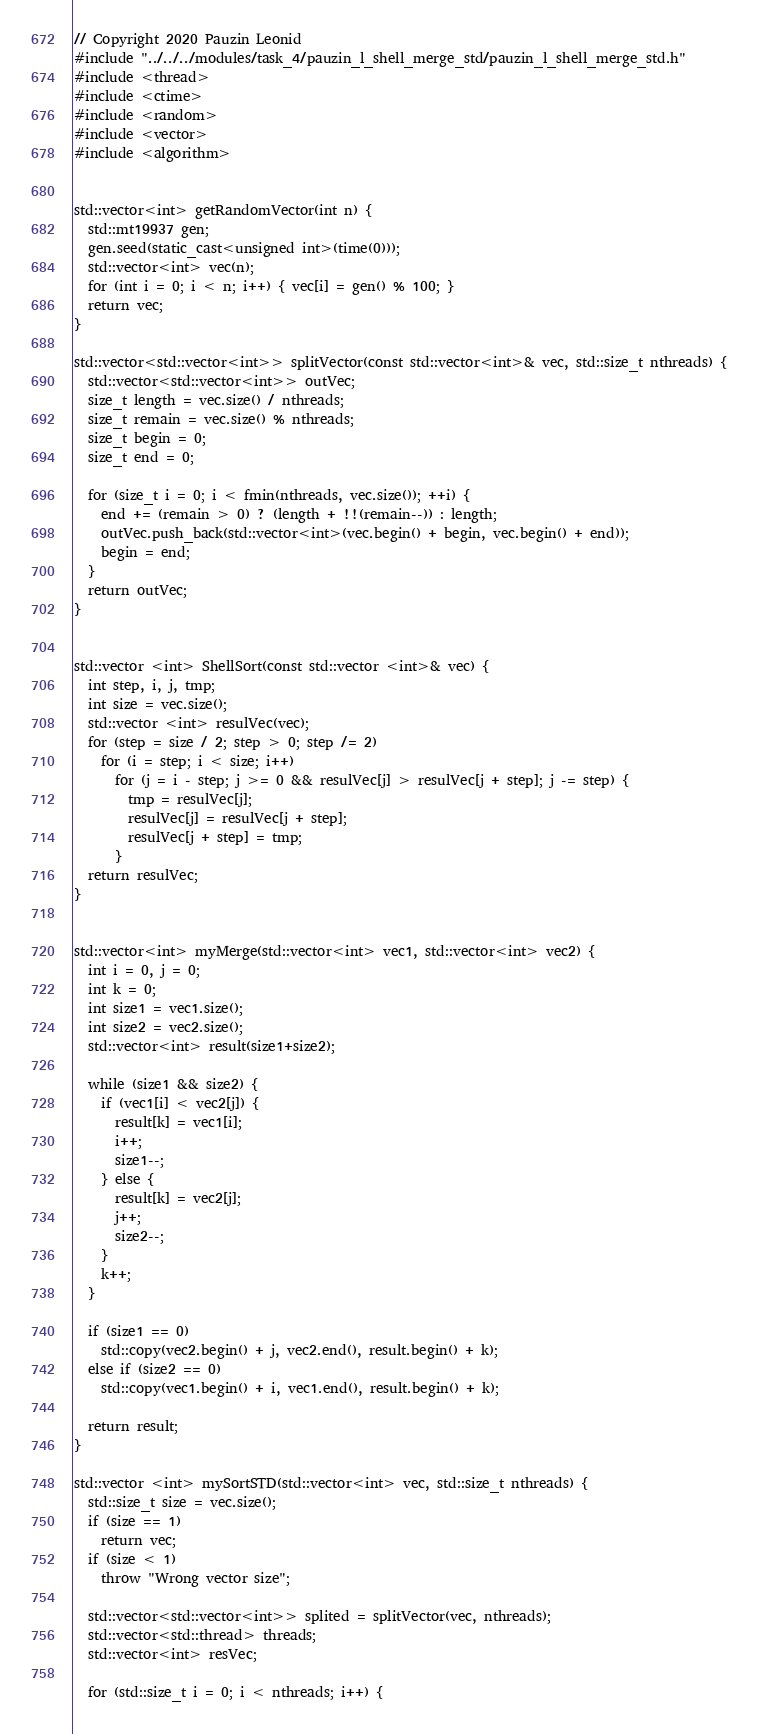<code> <loc_0><loc_0><loc_500><loc_500><_C++_>// Copyright 2020 Pauzin Leonid
#include "../../../modules/task_4/pauzin_l_shell_merge_std/pauzin_l_shell_merge_std.h"
#include <thread>
#include <ctime>
#include <random>
#include <vector>
#include <algorithm>


std::vector<int> getRandomVector(int n) {
  std::mt19937 gen;
  gen.seed(static_cast<unsigned int>(time(0)));
  std::vector<int> vec(n);
  for (int i = 0; i < n; i++) { vec[i] = gen() % 100; }
  return vec;
}

std::vector<std::vector<int>> splitVector(const std::vector<int>& vec, std::size_t nthreads) {
  std::vector<std::vector<int>> outVec;
  size_t length = vec.size() / nthreads;
  size_t remain = vec.size() % nthreads;
  size_t begin = 0;
  size_t end = 0;

  for (size_t i = 0; i < fmin(nthreads, vec.size()); ++i) {
    end += (remain > 0) ? (length + !!(remain--)) : length;
    outVec.push_back(std::vector<int>(vec.begin() + begin, vec.begin() + end));
    begin = end;
  }
  return outVec;
}


std::vector <int> ShellSort(const std::vector <int>& vec) {
  int step, i, j, tmp;
  int size = vec.size();
  std::vector <int> resulVec(vec);
  for (step = size / 2; step > 0; step /= 2)
    for (i = step; i < size; i++)
      for (j = i - step; j >= 0 && resulVec[j] > resulVec[j + step]; j -= step) {
        tmp = resulVec[j];
        resulVec[j] = resulVec[j + step];
        resulVec[j + step] = tmp;
      }
  return resulVec;
}


std::vector<int> myMerge(std::vector<int> vec1, std::vector<int> vec2) {
  int i = 0, j = 0;
  int k = 0;
  int size1 = vec1.size();
  int size2 = vec2.size();
  std::vector<int> result(size1+size2);

  while (size1 && size2) {
    if (vec1[i] < vec2[j]) {
      result[k] = vec1[i];
      i++;
      size1--;
    } else {
      result[k] = vec2[j];
      j++;
      size2--;
    }
    k++;
  }

  if (size1 == 0)
    std::copy(vec2.begin() + j, vec2.end(), result.begin() + k);
  else if (size2 == 0)
    std::copy(vec1.begin() + i, vec1.end(), result.begin() + k);

  return result;
}

std::vector <int> mySortSTD(std::vector<int> vec, std::size_t nthreads) {
  std::size_t size = vec.size();
  if (size == 1)
    return vec;
  if (size < 1)
    throw "Wrong vector size";

  std::vector<std::vector<int>> splited = splitVector(vec, nthreads);
  std::vector<std::thread> threads;
  std::vector<int> resVec;

  for (std::size_t i = 0; i < nthreads; i++) {</code> 